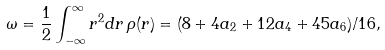Convert formula to latex. <formula><loc_0><loc_0><loc_500><loc_500>\omega = \frac { 1 } { 2 } \int _ { - \infty } ^ { \infty } r ^ { 2 } d r \, \rho ( r ) = ( 8 + 4 a _ { 2 } + 1 2 a _ { 4 } + 4 5 a _ { 6 } ) / 1 6 ,</formula> 